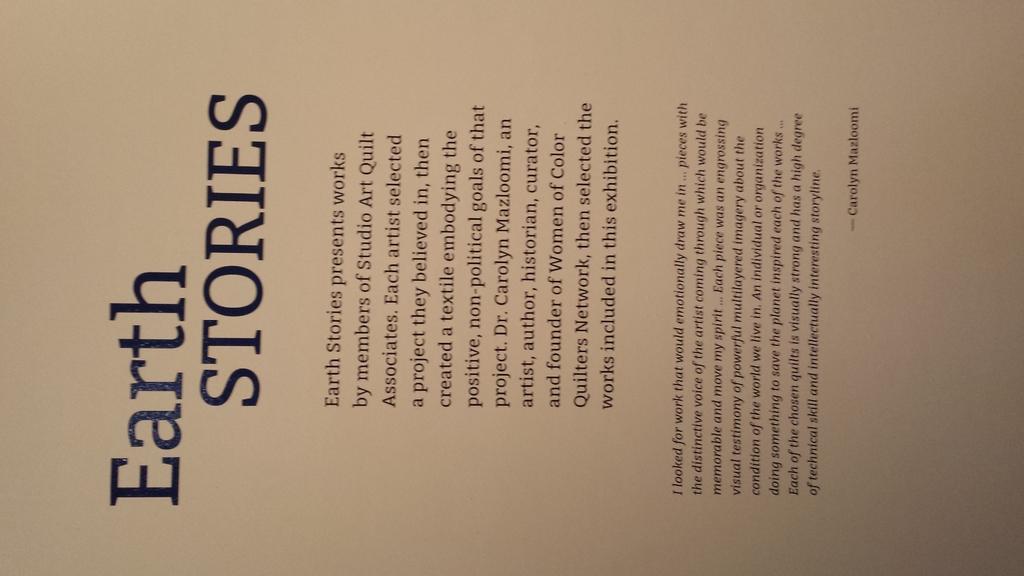What is the name of the collection of art being talked about?
Offer a very short reply. Earth stories. What is the title?
Your response must be concise. Earth stories. 